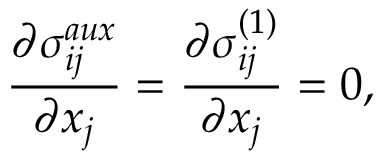<formula> <loc_0><loc_0><loc_500><loc_500>\frac { \partial \sigma _ { i j } ^ { a u x } } { \partial x _ { j } } = \frac { \partial \sigma _ { i j } ^ { ( 1 ) } } { \partial x _ { j } } = 0 ,</formula> 